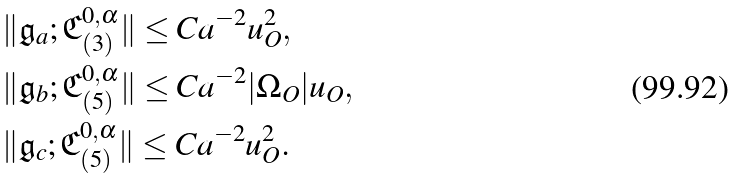Convert formula to latex. <formula><loc_0><loc_0><loc_500><loc_500>& \| \mathfrak { g } _ { a } ; \mathfrak { C } _ { ( 3 ) } ^ { 0 , \alpha } \| \leq C a ^ { - 2 } u _ { O } ^ { 2 } , \\ & \| \mathfrak { g } _ { b } ; \mathfrak { C } _ { ( 5 ) } ^ { 0 , \alpha } \| \leq C a ^ { - 2 } | \Omega _ { O } | u _ { O } , \\ & \| \mathfrak { g } _ { c } ; \mathfrak { C } _ { ( 5 ) } ^ { 0 , \alpha } \| \leq C a ^ { - 2 } u _ { O } ^ { 2 } .</formula> 